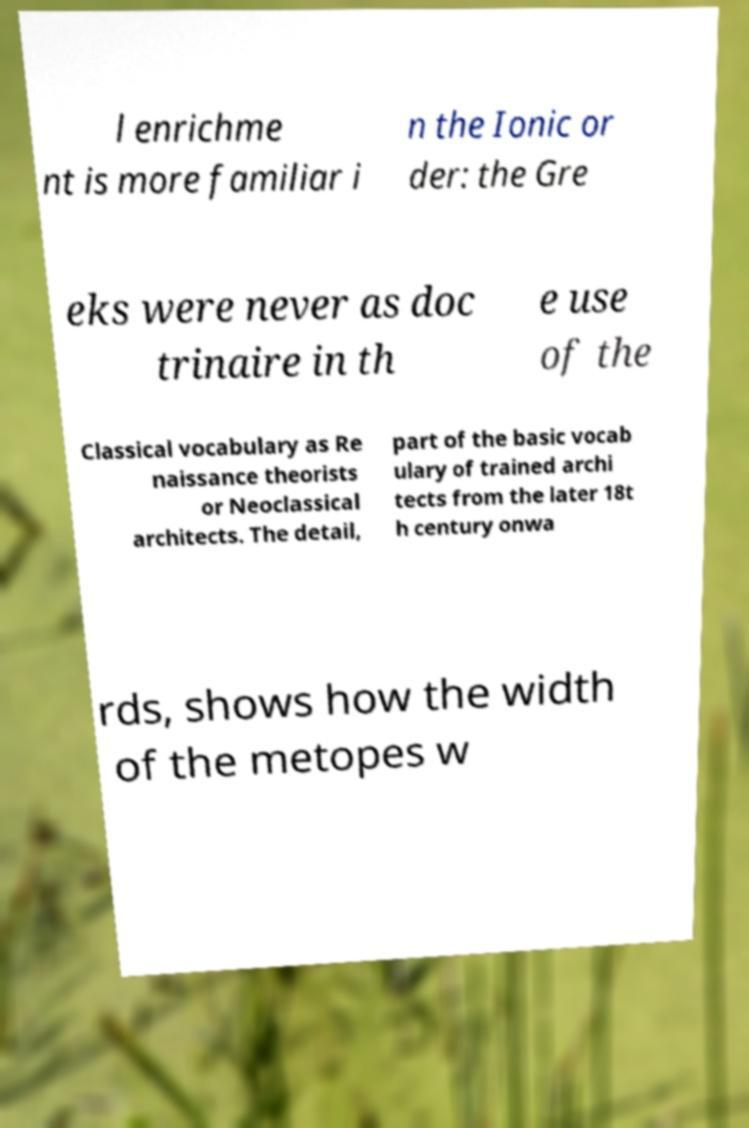Can you accurately transcribe the text from the provided image for me? l enrichme nt is more familiar i n the Ionic or der: the Gre eks were never as doc trinaire in th e use of the Classical vocabulary as Re naissance theorists or Neoclassical architects. The detail, part of the basic vocab ulary of trained archi tects from the later 18t h century onwa rds, shows how the width of the metopes w 